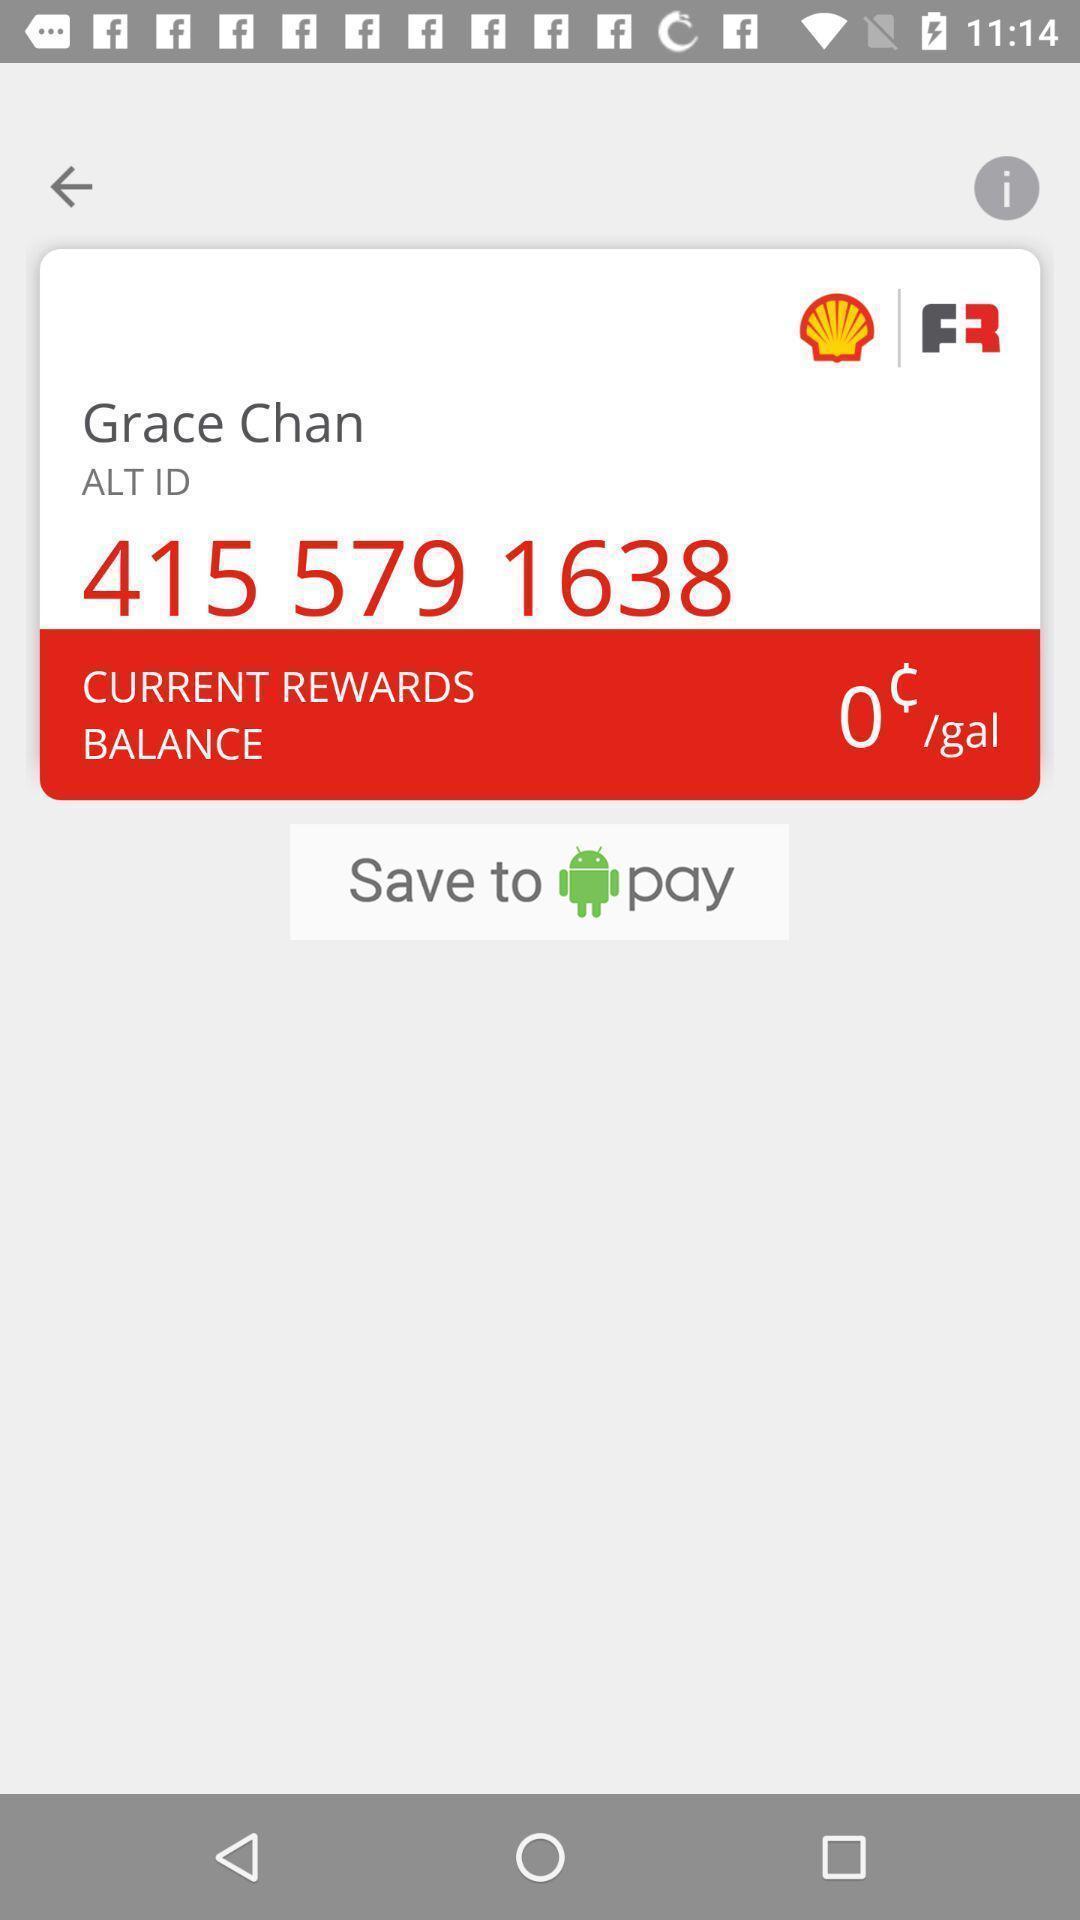Provide a textual representation of this image. Screen shows about instant gold status. 